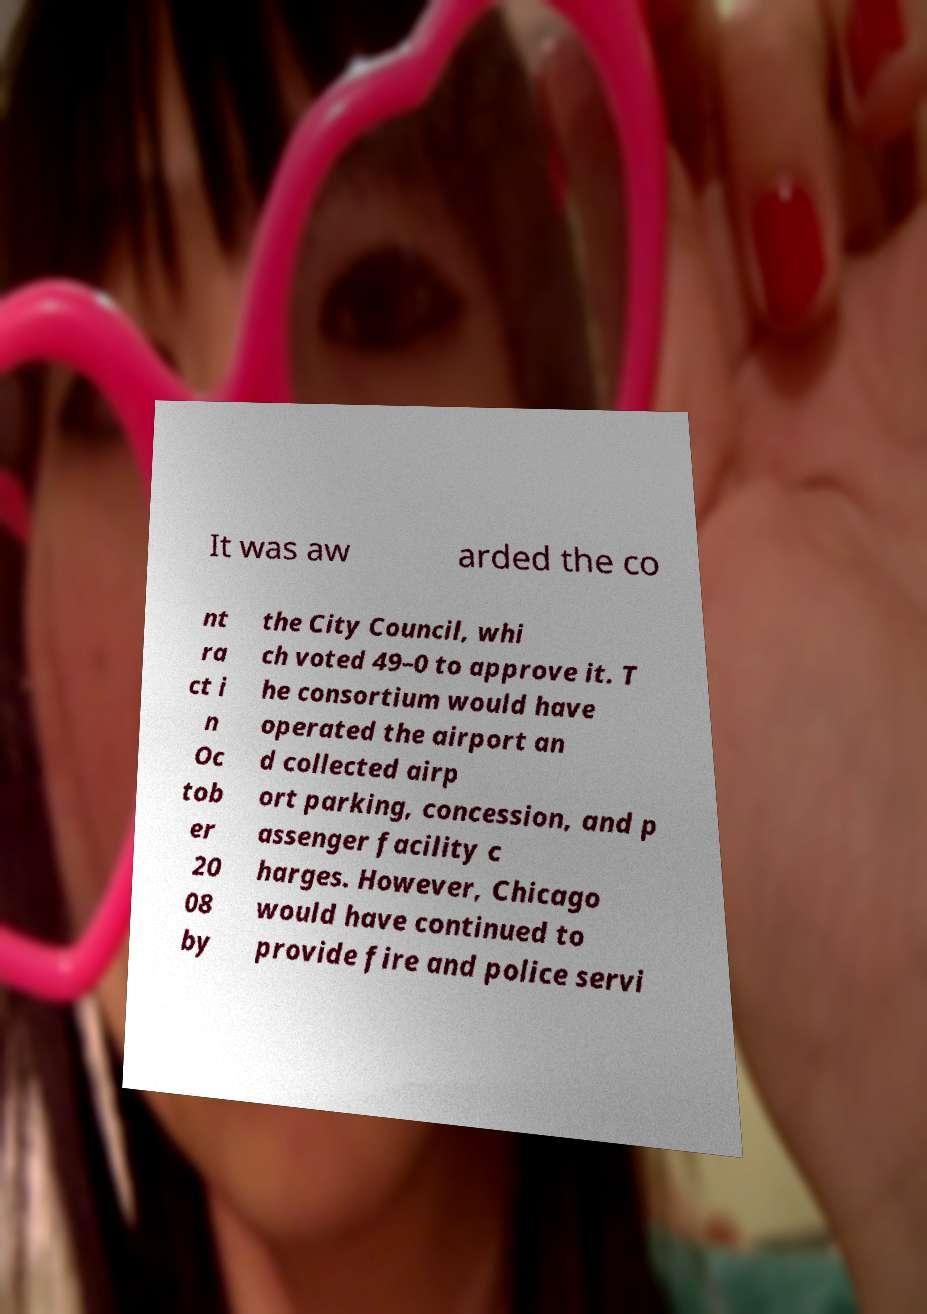Please identify and transcribe the text found in this image. It was aw arded the co nt ra ct i n Oc tob er 20 08 by the City Council, whi ch voted 49–0 to approve it. T he consortium would have operated the airport an d collected airp ort parking, concession, and p assenger facility c harges. However, Chicago would have continued to provide fire and police servi 